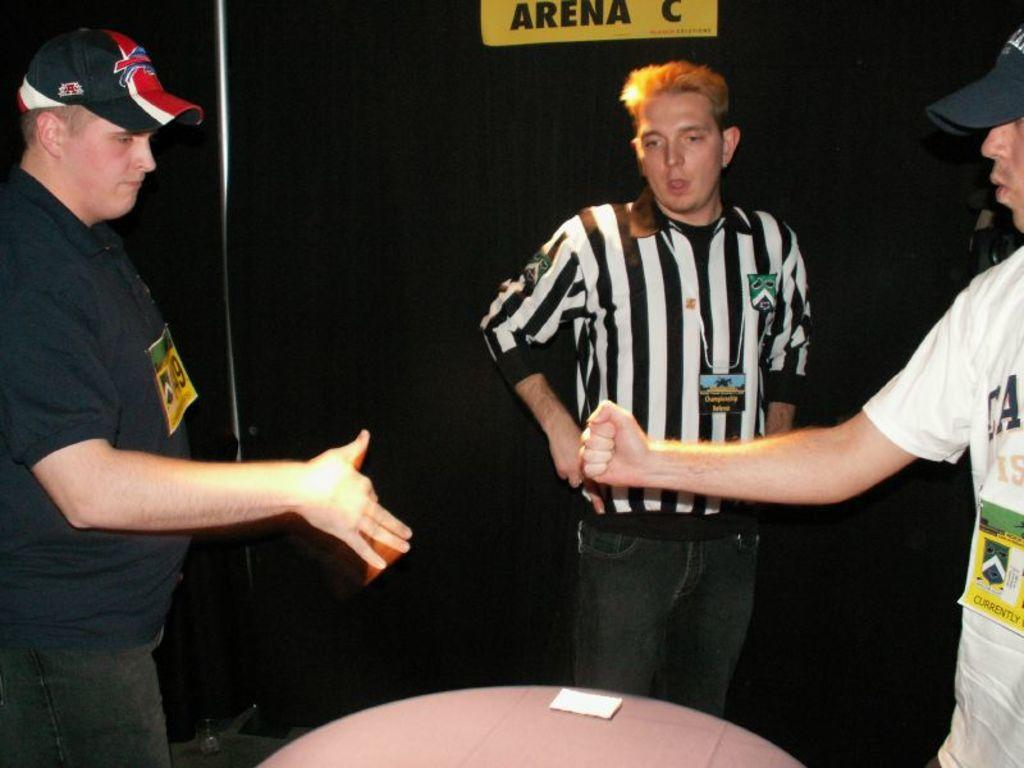<image>
Render a clear and concise summary of the photo. two men about to hold hands by a sign for Arena C 